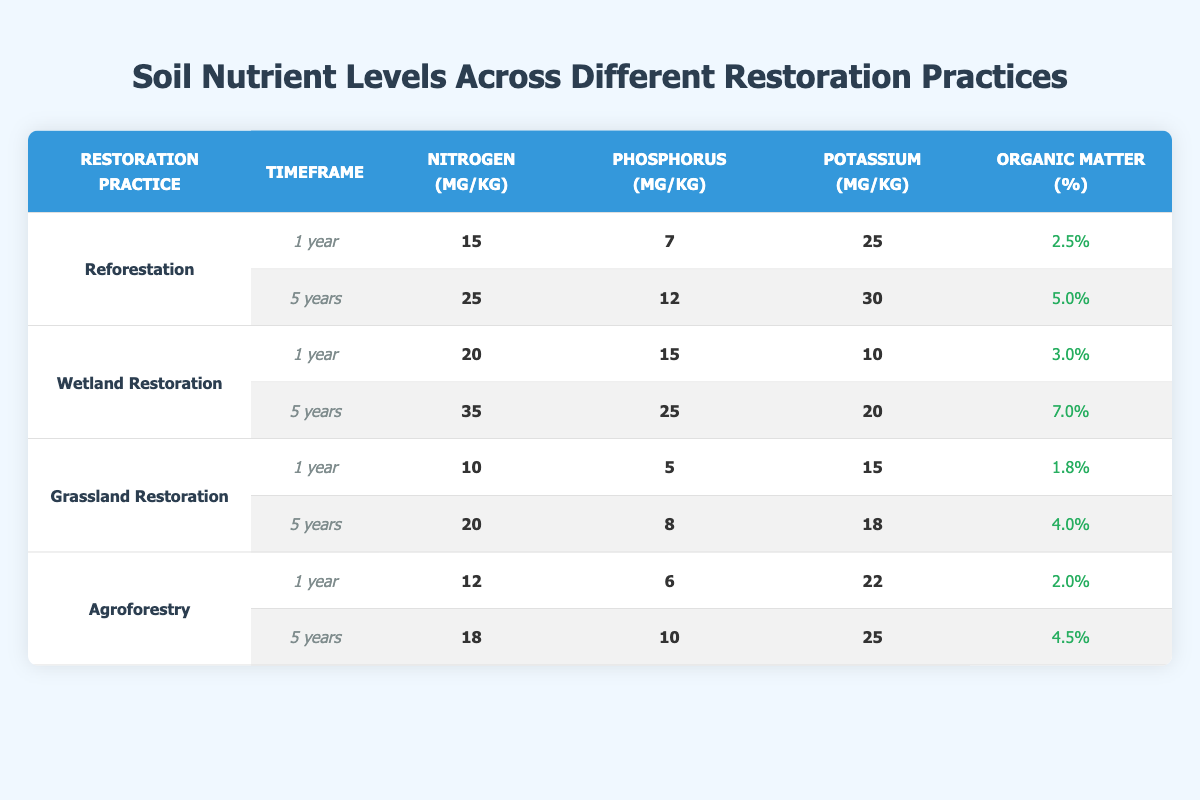What is the nitrogen level in soil after 5 years of reforestation? The table shows that for reforestation at a 5-year timeframe, the nitrogen level is 25 mg/kg.
Answer: 25 mg/kg Which restoration practice had the highest phosphorus level after 1 year? Looking at the 1-year timeframe for all practices, Wetland Restoration has the highest phosphorus level at 15 mg/kg.
Answer: Wetland Restoration What is the difference in potassium levels between Grassland Restoration after 1 year and 5 years? For Grassland Restoration, the potassium level after 1 year is 15 mg/kg and after 5 years is 18 mg/kg. The difference is 18 - 15 = 3 mg/kg.
Answer: 3 mg/kg Is the organic matter percentage higher in Wetland Restoration after 5 years than in Agroforestry after 1 year? Wetland Restoration after 5 years has an organic matter percentage of 7.0%, while Agroforestry after 1 year has 2.0%. Since 7.0% is greater than 2.0%, the statement is true.
Answer: Yes What is the average nitrogen level across all restoration practices for the 5-year timeframe? The nitrogen levels for the 5-year timeframe are 25 (Reforestation), 35 (Wetland Restoration), 20 (Grassland Restoration), and 18 (Agroforestry). Summing these gives 25 + 35 + 20 + 18 = 98 mg/kg. There are 4 practices, so the average is 98 / 4 = 24.5 mg/kg.
Answer: 24.5 mg/kg What is the potassium level in soil for Agroforestry after 5 years? The table indicates that for Agroforestry at the 5-year mark, the potassium level is 25 mg/kg.
Answer: 25 mg/kg Is it true that Grassland Restoration shows an increase in nitrogen levels from 1 year to 5 years? The nitrogen level for Grassland Restoration after 1 year is 10 mg/kg and after 5 years is 20 mg/kg. Since 20 is greater than 10, the statement is true.
Answer: Yes Which restoration practice had the lowest organic matter percentage after 1 year? In the 1-year timeframe, Grassland Restoration has the lowest organic matter percentage at 1.8%.
Answer: Grassland Restoration 